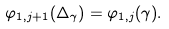<formula> <loc_0><loc_0><loc_500><loc_500>\varphi _ { 1 , j + 1 } ( \Delta _ { \gamma } ) = \varphi _ { 1 , j } ( \gamma ) .</formula> 